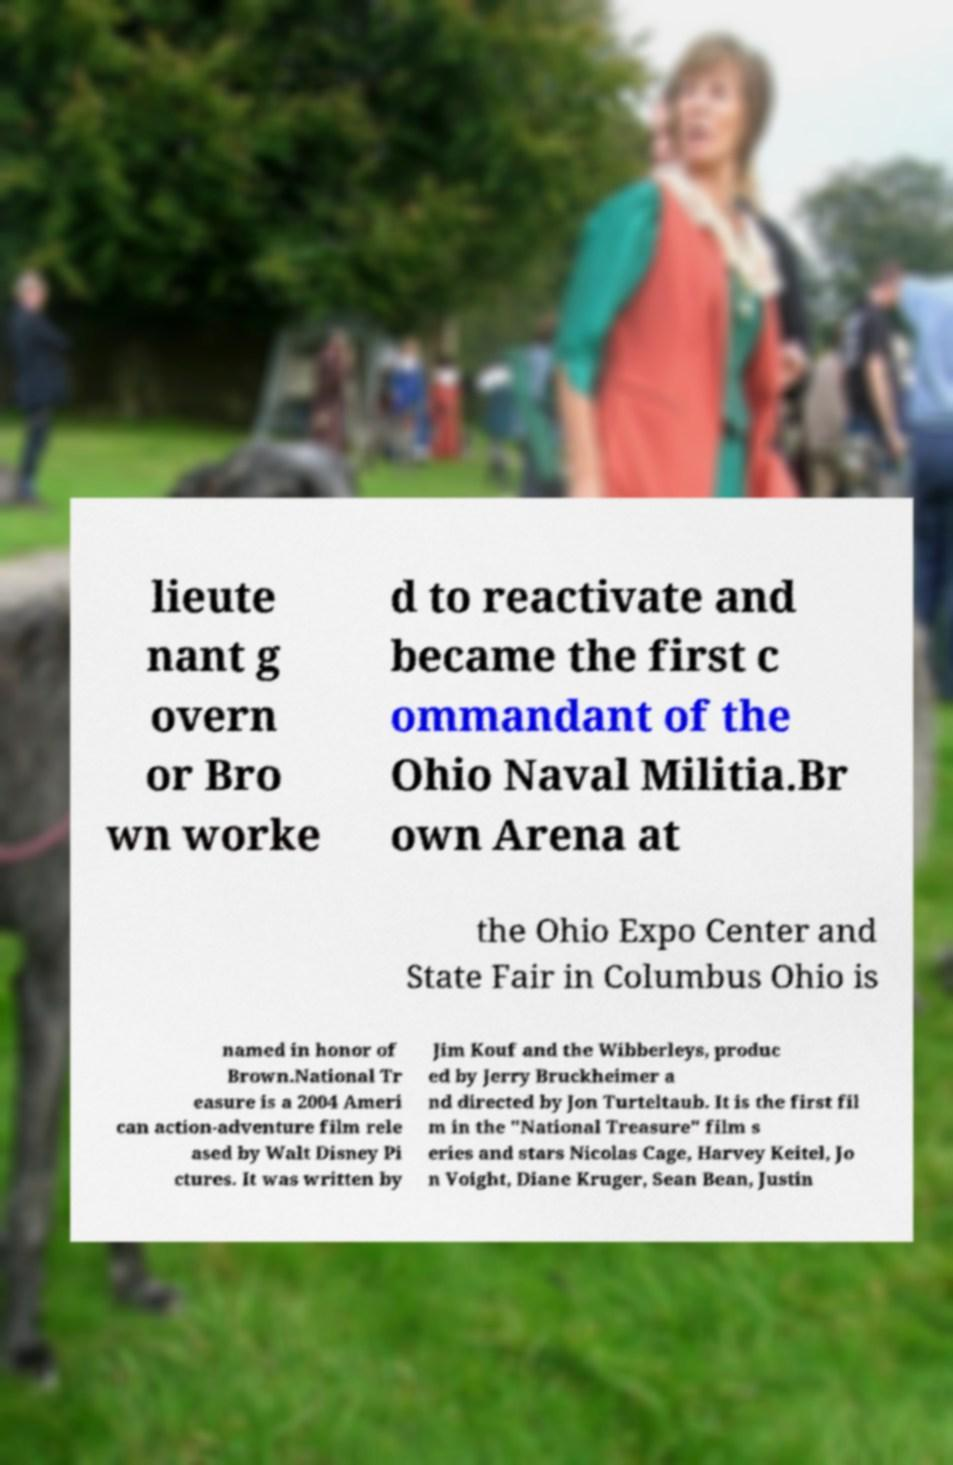There's text embedded in this image that I need extracted. Can you transcribe it verbatim? lieute nant g overn or Bro wn worke d to reactivate and became the first c ommandant of the Ohio Naval Militia.Br own Arena at the Ohio Expo Center and State Fair in Columbus Ohio is named in honor of Brown.National Tr easure is a 2004 Ameri can action-adventure film rele ased by Walt Disney Pi ctures. It was written by Jim Kouf and the Wibberleys, produc ed by Jerry Bruckheimer a nd directed by Jon Turteltaub. It is the first fil m in the "National Treasure" film s eries and stars Nicolas Cage, Harvey Keitel, Jo n Voight, Diane Kruger, Sean Bean, Justin 